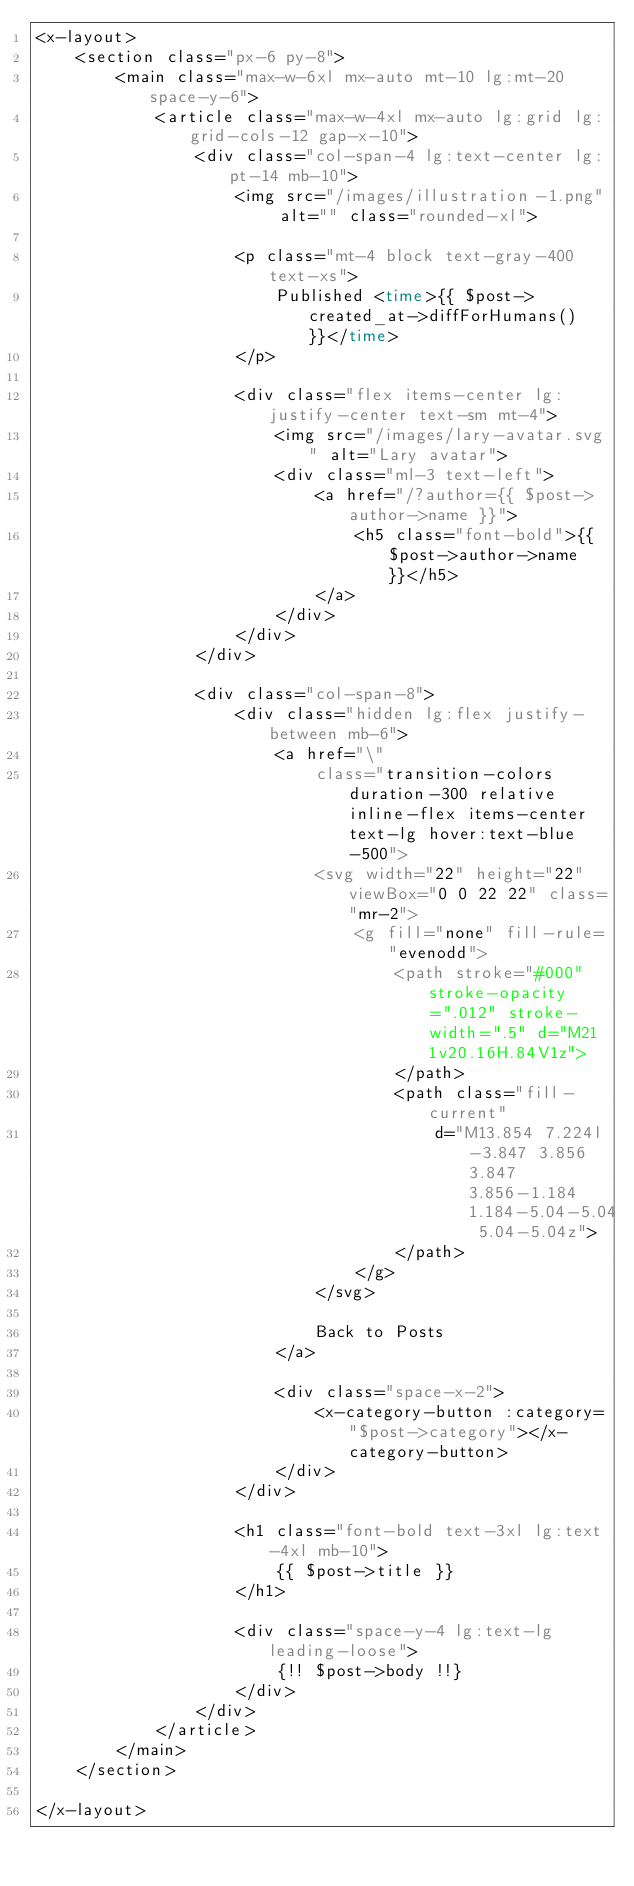<code> <loc_0><loc_0><loc_500><loc_500><_PHP_><x-layout>
    <section class="px-6 py-8">
        <main class="max-w-6xl mx-auto mt-10 lg:mt-20 space-y-6">
            <article class="max-w-4xl mx-auto lg:grid lg:grid-cols-12 gap-x-10">
                <div class="col-span-4 lg:text-center lg:pt-14 mb-10">
                    <img src="/images/illustration-1.png" alt="" class="rounded-xl">

                    <p class="mt-4 block text-gray-400 text-xs">
                        Published <time>{{ $post->created_at->diffForHumans() }}</time>
                    </p>

                    <div class="flex items-center lg:justify-center text-sm mt-4">
                        <img src="/images/lary-avatar.svg" alt="Lary avatar">
                        <div class="ml-3 text-left">
                            <a href="/?author={{ $post->author->name }}">
                                <h5 class="font-bold">{{ $post->author->name }}</h5>
                            </a>
                        </div>
                    </div>
                </div>

                <div class="col-span-8">
                    <div class="hidden lg:flex justify-between mb-6">
                        <a href="\"
                            class="transition-colors duration-300 relative inline-flex items-center text-lg hover:text-blue-500">
                            <svg width="22" height="22" viewBox="0 0 22 22" class="mr-2">
                                <g fill="none" fill-rule="evenodd">
                                    <path stroke="#000" stroke-opacity=".012" stroke-width=".5" d="M21 1v20.16H.84V1z">
                                    </path>
                                    <path class="fill-current"
                                        d="M13.854 7.224l-3.847 3.856 3.847 3.856-1.184 1.184-5.04-5.04 5.04-5.04z">
                                    </path>
                                </g>
                            </svg>

                            Back to Posts
                        </a>

                        <div class="space-x-2">
                            <x-category-button :category="$post->category"></x-category-button>
                        </div>
                    </div>

                    <h1 class="font-bold text-3xl lg:text-4xl mb-10">
                        {{ $post->title }}
                    </h1>

                    <div class="space-y-4 lg:text-lg leading-loose">
                        {!! $post->body !!}
                    </div>
                </div>
            </article>
        </main>
    </section>

</x-layout>
</code> 